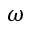Convert formula to latex. <formula><loc_0><loc_0><loc_500><loc_500>\omega</formula> 